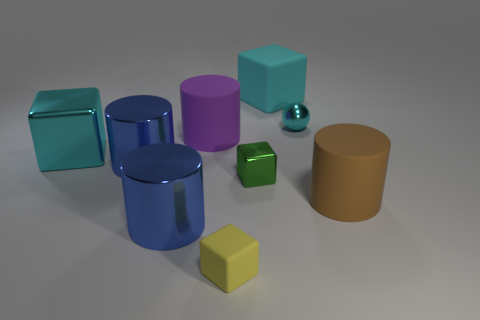Could you tell me the different shapes you see and which one looks the smallest? Of course! The image presents a variety of shapes including cubes, cylinders, and a sphere. We can see two cylinders, one large and one smaller, three cubes of different sizes and a shiny reflective sphere. The green cube appears to be the smallest among all the shapes presented. Which object stands out the most to you and why? The shiny reflective ball immediately draws attention due to its unique surface texture that stands out among the matte finishes of the other objects. Its reflective surface catches the light and reflects the environment, making it a captivating focal point. 